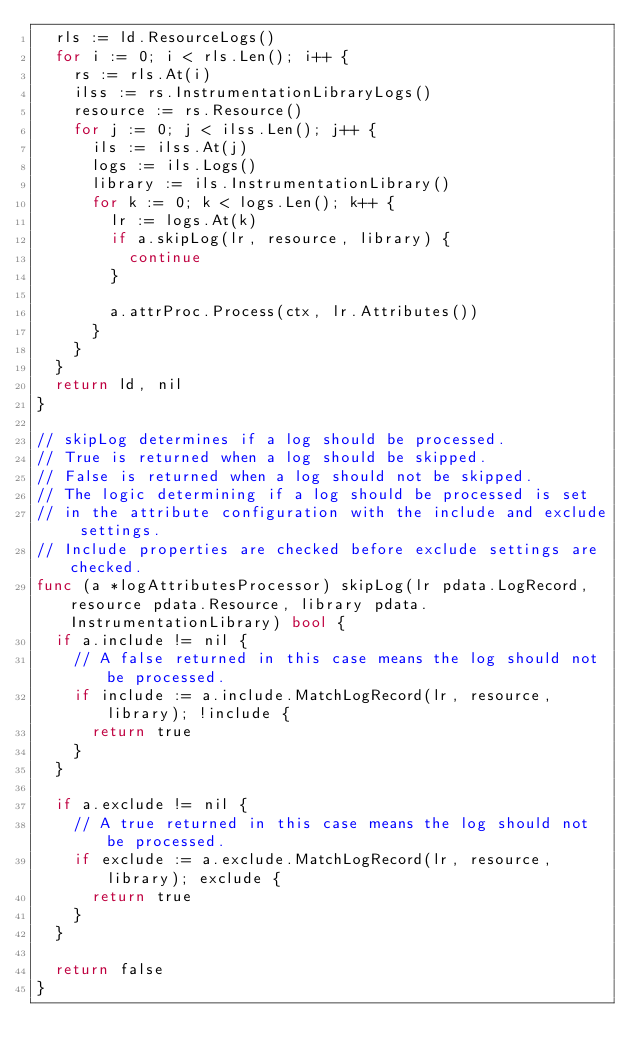<code> <loc_0><loc_0><loc_500><loc_500><_Go_>	rls := ld.ResourceLogs()
	for i := 0; i < rls.Len(); i++ {
		rs := rls.At(i)
		ilss := rs.InstrumentationLibraryLogs()
		resource := rs.Resource()
		for j := 0; j < ilss.Len(); j++ {
			ils := ilss.At(j)
			logs := ils.Logs()
			library := ils.InstrumentationLibrary()
			for k := 0; k < logs.Len(); k++ {
				lr := logs.At(k)
				if a.skipLog(lr, resource, library) {
					continue
				}

				a.attrProc.Process(ctx, lr.Attributes())
			}
		}
	}
	return ld, nil
}

// skipLog determines if a log should be processed.
// True is returned when a log should be skipped.
// False is returned when a log should not be skipped.
// The logic determining if a log should be processed is set
// in the attribute configuration with the include and exclude settings.
// Include properties are checked before exclude settings are checked.
func (a *logAttributesProcessor) skipLog(lr pdata.LogRecord, resource pdata.Resource, library pdata.InstrumentationLibrary) bool {
	if a.include != nil {
		// A false returned in this case means the log should not be processed.
		if include := a.include.MatchLogRecord(lr, resource, library); !include {
			return true
		}
	}

	if a.exclude != nil {
		// A true returned in this case means the log should not be processed.
		if exclude := a.exclude.MatchLogRecord(lr, resource, library); exclude {
			return true
		}
	}

	return false
}
</code> 